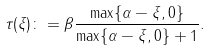Convert formula to latex. <formula><loc_0><loc_0><loc_500><loc_500>\tau ( \xi ) \colon = \beta \frac { \max \{ \alpha - \xi , 0 \} } { \max \{ \alpha - \xi , 0 \} + 1 } .</formula> 